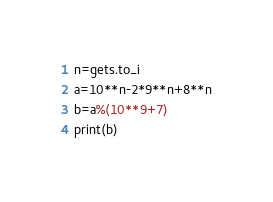<code> <loc_0><loc_0><loc_500><loc_500><_Ruby_>n=gets.to_i
a=10**n-2*9**n+8**n
b=a%(10**9+7)
print(b)</code> 